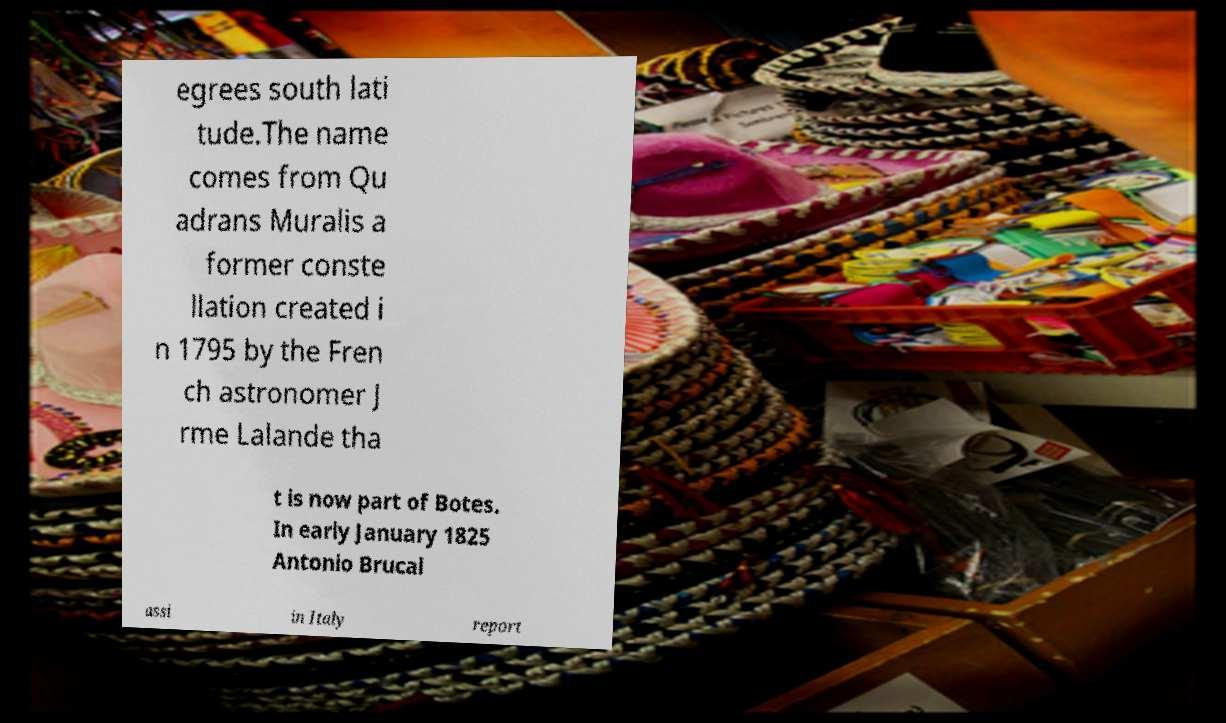I need the written content from this picture converted into text. Can you do that? egrees south lati tude.The name comes from Qu adrans Muralis a former conste llation created i n 1795 by the Fren ch astronomer J rme Lalande tha t is now part of Botes. In early January 1825 Antonio Brucal assi in Italy report 